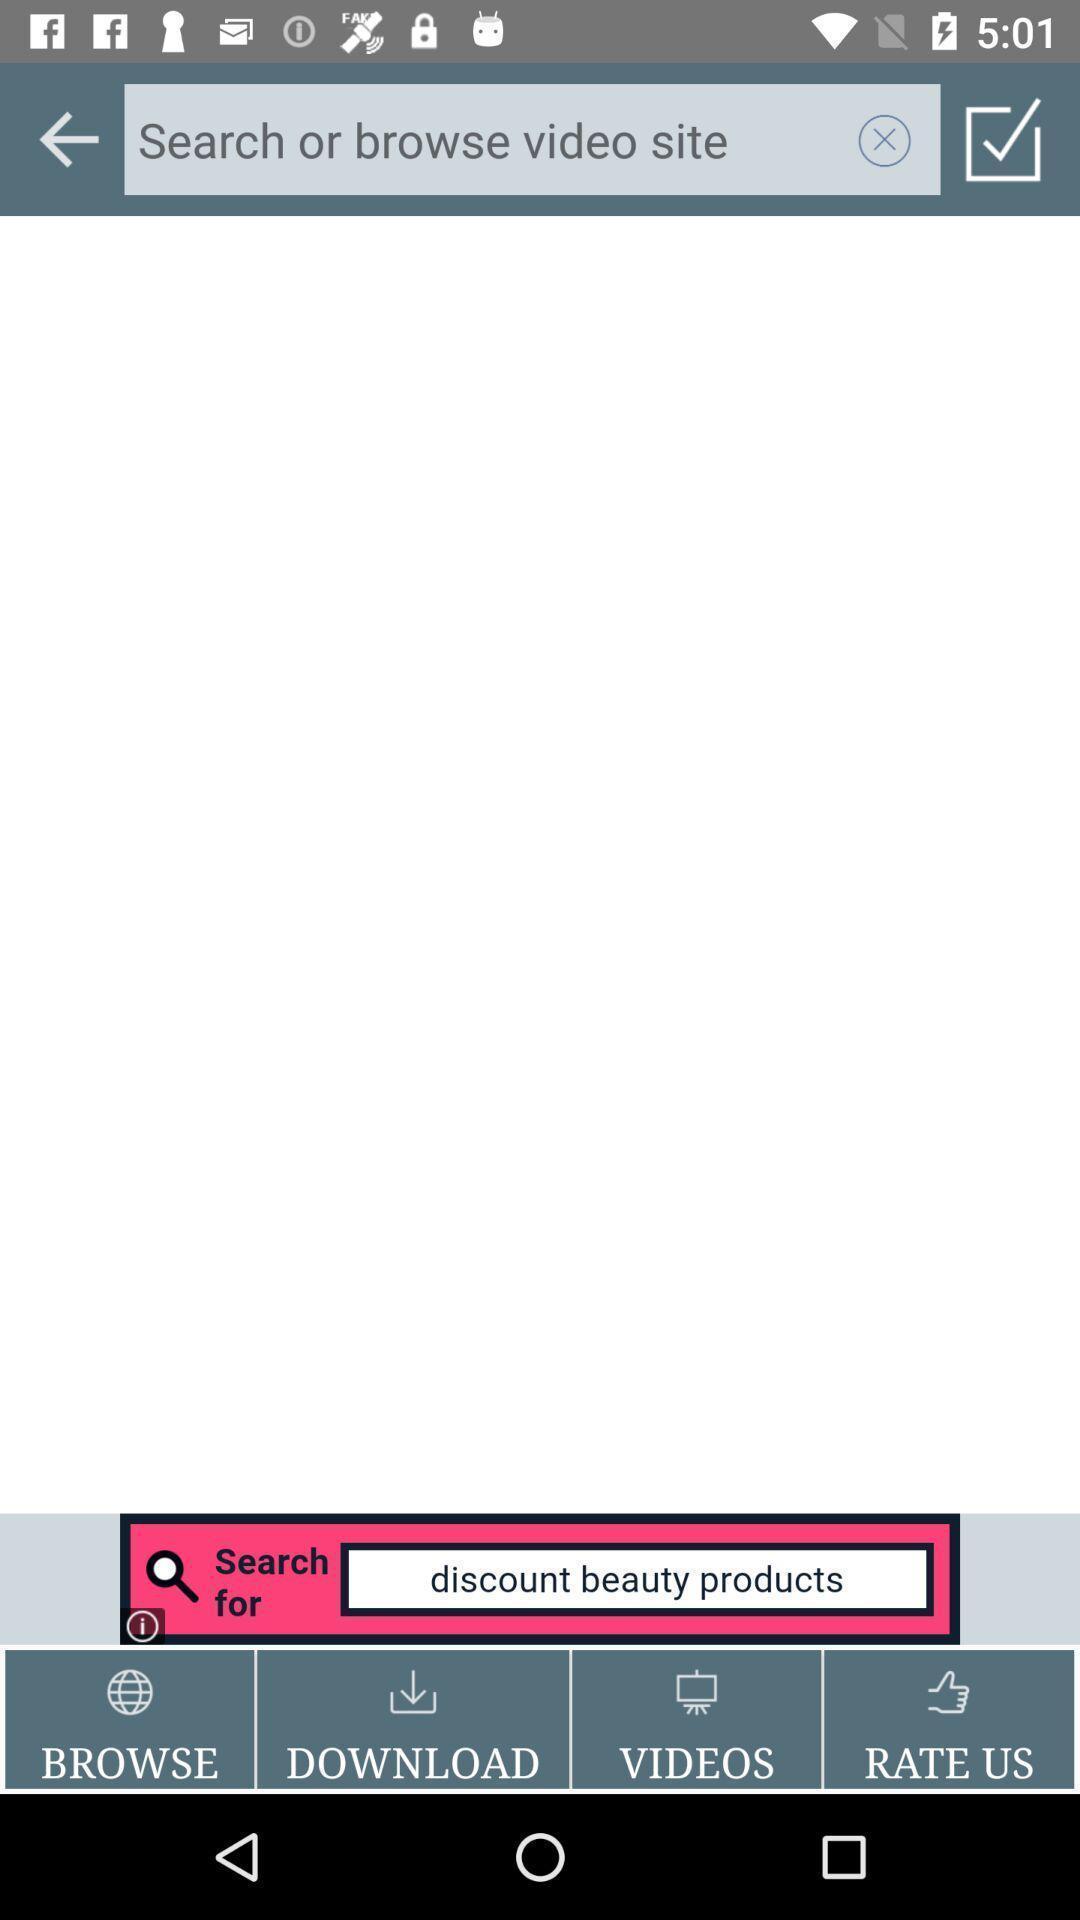Tell me what you see in this picture. Search page with various options. 